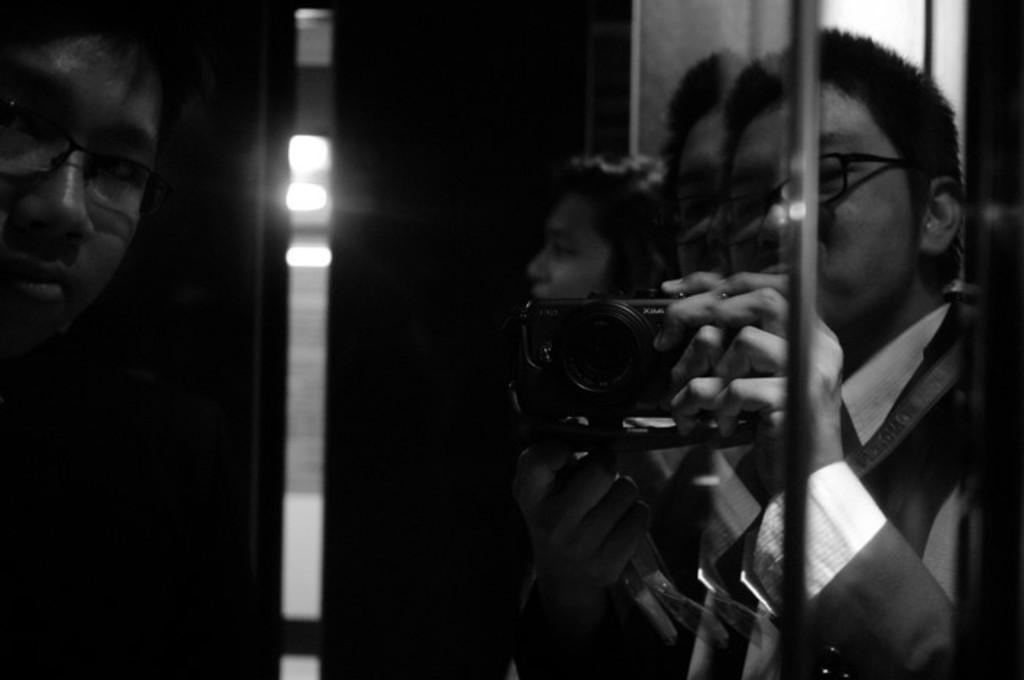What is the color scheme of the image? The image is black and white. How many people are in the image? There are four persons in the image. What is one person doing in the image? One person is holding a camera. How many of the persons in the image are wearing glasses? Two persons are wearing glasses. What can be seen in the background of the image? There is a wall in the background of the image. What type of cat can be seen participating in the event in the image? There is no cat or event present in the image; it features four persons and a wall in the background. 